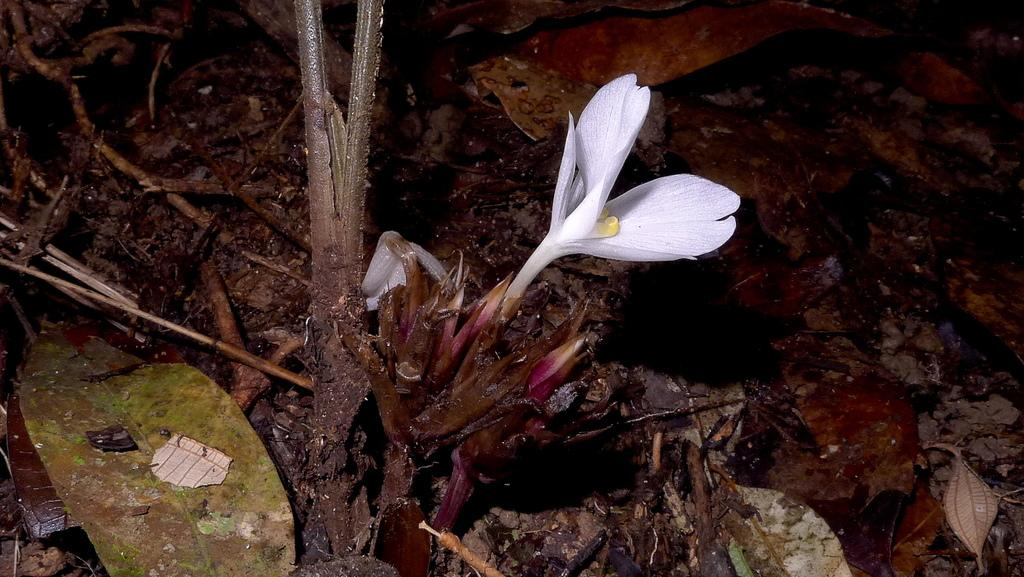What is the main subject in the middle of the image? There is a white flower in the middle of the image. What can be seen at the bottom of the image? There are leaves at the bottom of the image. What type of plant material is present in the image? There are dry sticks in the image. What can be seen on the right side of the image? There are dry leaves on the ground on the right side of the image. Can you describe the woman's experience with the squirrel in the image? There is: There is no woman or squirrel present in the image, so it is not possible to describe any experience involving them. 